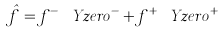<formula> <loc_0><loc_0><loc_500><loc_500>\hat { f } = f ^ { - } \ Y z e r o ^ { - } + f ^ { + } \ Y z e r o ^ { + }</formula> 